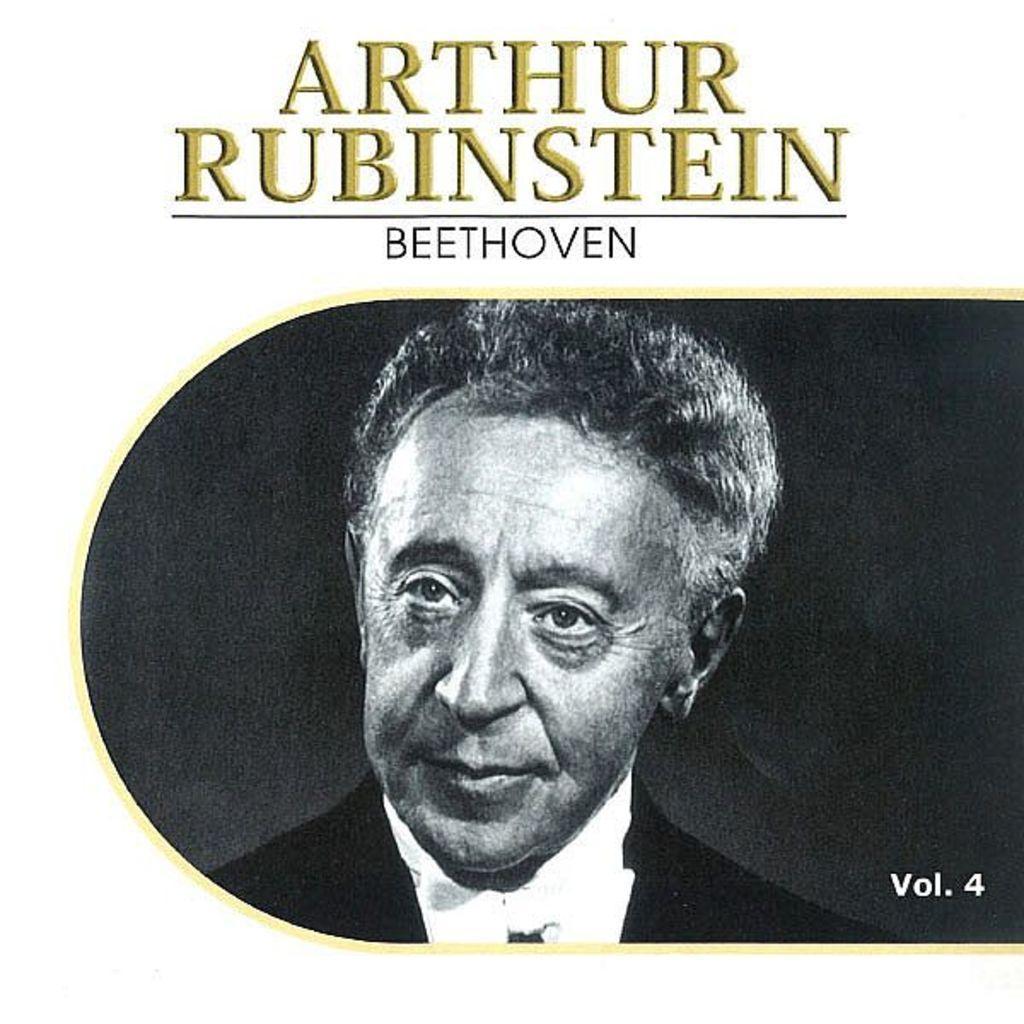Can you describe this image briefly? In this picture we can see a poster. In this poster, we can see a person. 